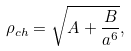Convert formula to latex. <formula><loc_0><loc_0><loc_500><loc_500>\rho _ { c h } = \sqrt { A + \frac { B } { a ^ { 6 } } } ,</formula> 